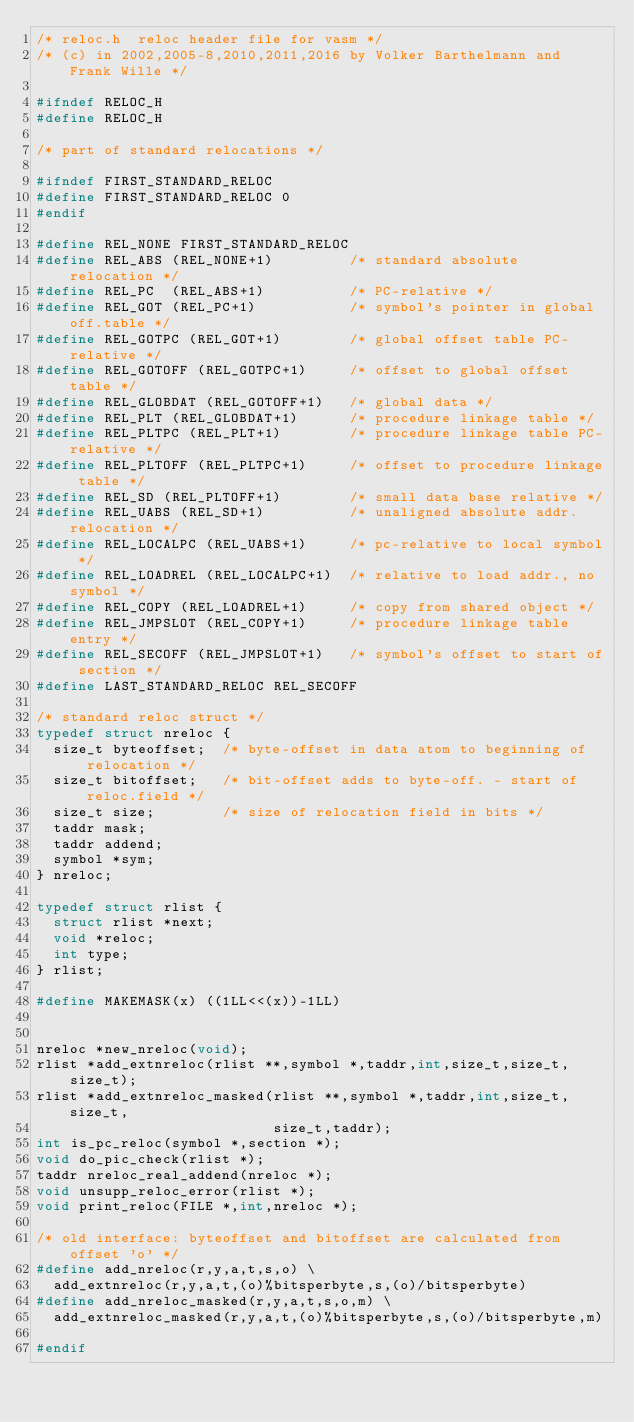Convert code to text. <code><loc_0><loc_0><loc_500><loc_500><_C_>/* reloc.h  reloc header file for vasm */
/* (c) in 2002,2005-8,2010,2011,2016 by Volker Barthelmann and Frank Wille */

#ifndef RELOC_H
#define RELOC_H

/* part of standard relocations */

#ifndef FIRST_STANDARD_RELOC
#define FIRST_STANDARD_RELOC 0
#endif

#define REL_NONE FIRST_STANDARD_RELOC
#define REL_ABS (REL_NONE+1)         /* standard absolute relocation */
#define REL_PC  (REL_ABS+1)          /* PC-relative */
#define REL_GOT (REL_PC+1)           /* symbol's pointer in global off.table */
#define REL_GOTPC (REL_GOT+1)        /* global offset table PC-relative */
#define REL_GOTOFF (REL_GOTPC+1)     /* offset to global offset table */
#define REL_GLOBDAT (REL_GOTOFF+1)   /* global data */
#define REL_PLT (REL_GLOBDAT+1)      /* procedure linkage table */
#define REL_PLTPC (REL_PLT+1)        /* procedure linkage table PC-relative */
#define REL_PLTOFF (REL_PLTPC+1)     /* offset to procedure linkage table */
#define REL_SD (REL_PLTOFF+1)        /* small data base relative */
#define REL_UABS (REL_SD+1)          /* unaligned absolute addr. relocation */
#define REL_LOCALPC (REL_UABS+1)     /* pc-relative to local symbol */
#define REL_LOADREL (REL_LOCALPC+1)  /* relative to load addr., no symbol */
#define REL_COPY (REL_LOADREL+1)     /* copy from shared object */
#define REL_JMPSLOT (REL_COPY+1)     /* procedure linkage table entry */
#define REL_SECOFF (REL_JMPSLOT+1)   /* symbol's offset to start of section */
#define LAST_STANDARD_RELOC REL_SECOFF

/* standard reloc struct */
typedef struct nreloc {
  size_t byteoffset;  /* byte-offset in data atom to beginning of relocation */
  size_t bitoffset;   /* bit-offset adds to byte-off. - start of reloc.field */
  size_t size;        /* size of relocation field in bits */
  taddr mask;
  taddr addend;
  symbol *sym;
} nreloc;

typedef struct rlist {
  struct rlist *next;
  void *reloc;
  int type;
} rlist;

#define MAKEMASK(x) ((1LL<<(x))-1LL)


nreloc *new_nreloc(void);
rlist *add_extnreloc(rlist **,symbol *,taddr,int,size_t,size_t,size_t);
rlist *add_extnreloc_masked(rlist **,symbol *,taddr,int,size_t,size_t,
                            size_t,taddr);
int is_pc_reloc(symbol *,section *);
void do_pic_check(rlist *);
taddr nreloc_real_addend(nreloc *);
void unsupp_reloc_error(rlist *);
void print_reloc(FILE *,int,nreloc *);

/* old interface: byteoffset and bitoffset are calculated from offset 'o' */
#define add_nreloc(r,y,a,t,s,o) \
  add_extnreloc(r,y,a,t,(o)%bitsperbyte,s,(o)/bitsperbyte)
#define add_nreloc_masked(r,y,a,t,s,o,m) \
  add_extnreloc_masked(r,y,a,t,(o)%bitsperbyte,s,(o)/bitsperbyte,m)

#endif
</code> 